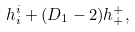<formula> <loc_0><loc_0><loc_500><loc_500>h ^ { i } _ { i } + ( D _ { 1 } - 2 ) h ^ { + } _ { + } ,</formula> 